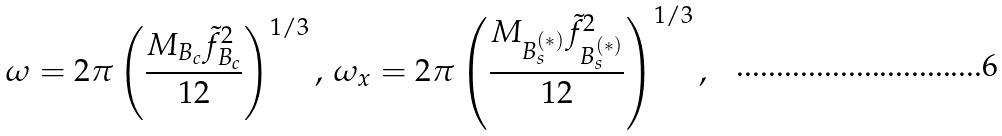Convert formula to latex. <formula><loc_0><loc_0><loc_500><loc_500>\omega = 2 \pi \left ( \frac { M _ { B _ { c } } \tilde { f } _ { B _ { c } } ^ { 2 } } { 1 2 } \right ) ^ { 1 / 3 } , \, \omega _ { x } = 2 \pi \left ( \frac { M _ { B _ { s } ^ { ( * ) } } \tilde { f } ^ { 2 } _ { B _ { s } ^ { ( * ) } } } { 1 2 } \right ) ^ { 1 / 3 } ,</formula> 